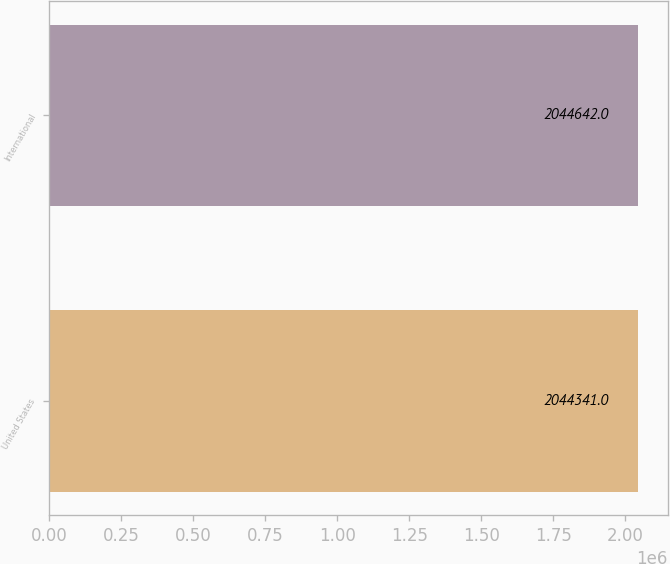Convert chart. <chart><loc_0><loc_0><loc_500><loc_500><bar_chart><fcel>United States<fcel>International<nl><fcel>2.04434e+06<fcel>2.04464e+06<nl></chart> 